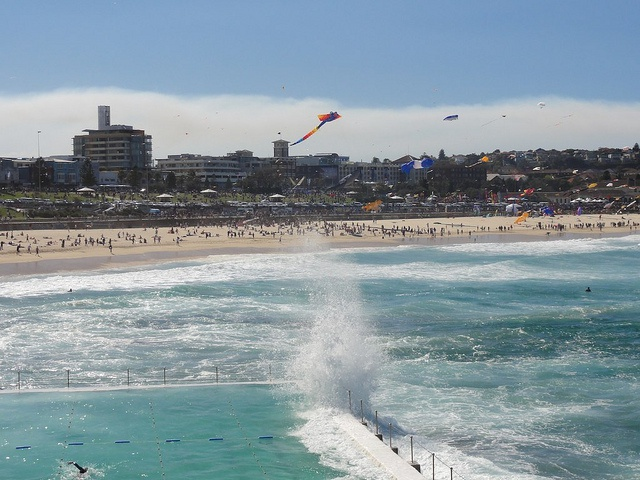Describe the objects in this image and their specific colors. I can see people in darkgray, gray, black, and lightgray tones, kite in darkgray, navy, purple, lightgray, and brown tones, kite in darkgray, gray, and brown tones, kite in darkgray, maroon, brown, and black tones, and kite in darkgray, navy, and gray tones in this image. 